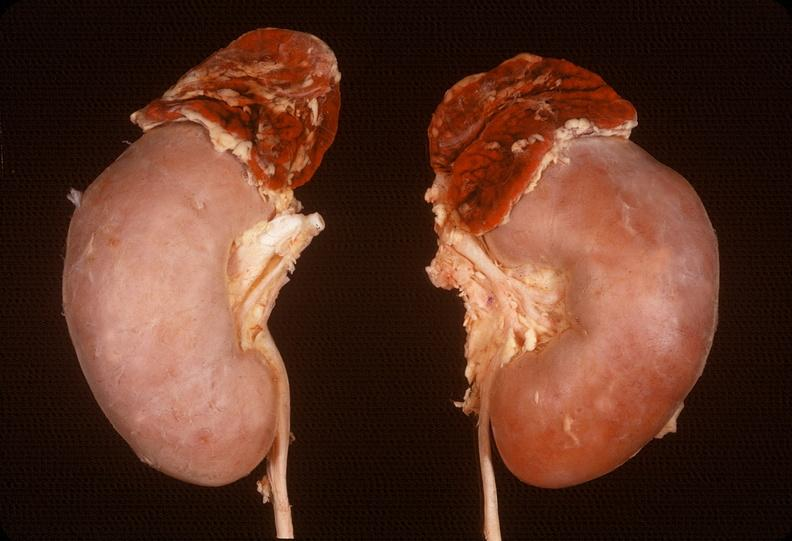what is present?
Answer the question using a single word or phrase. Endocrine 